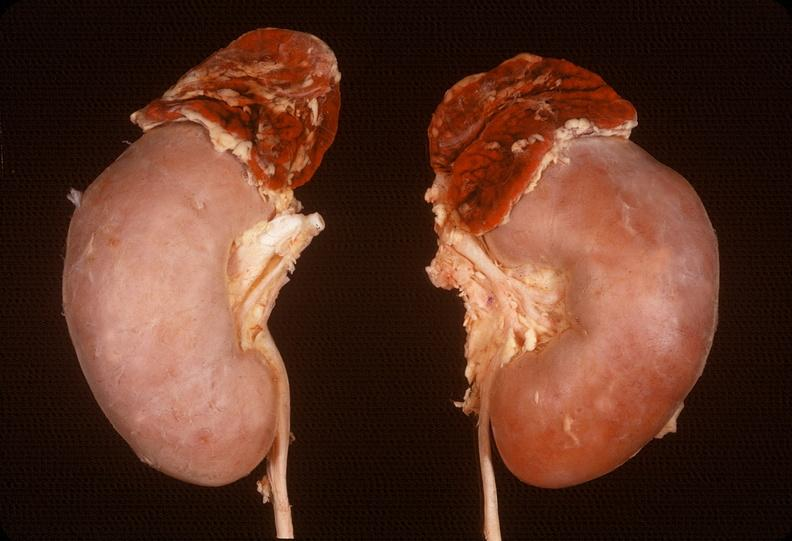what is present?
Answer the question using a single word or phrase. Endocrine 